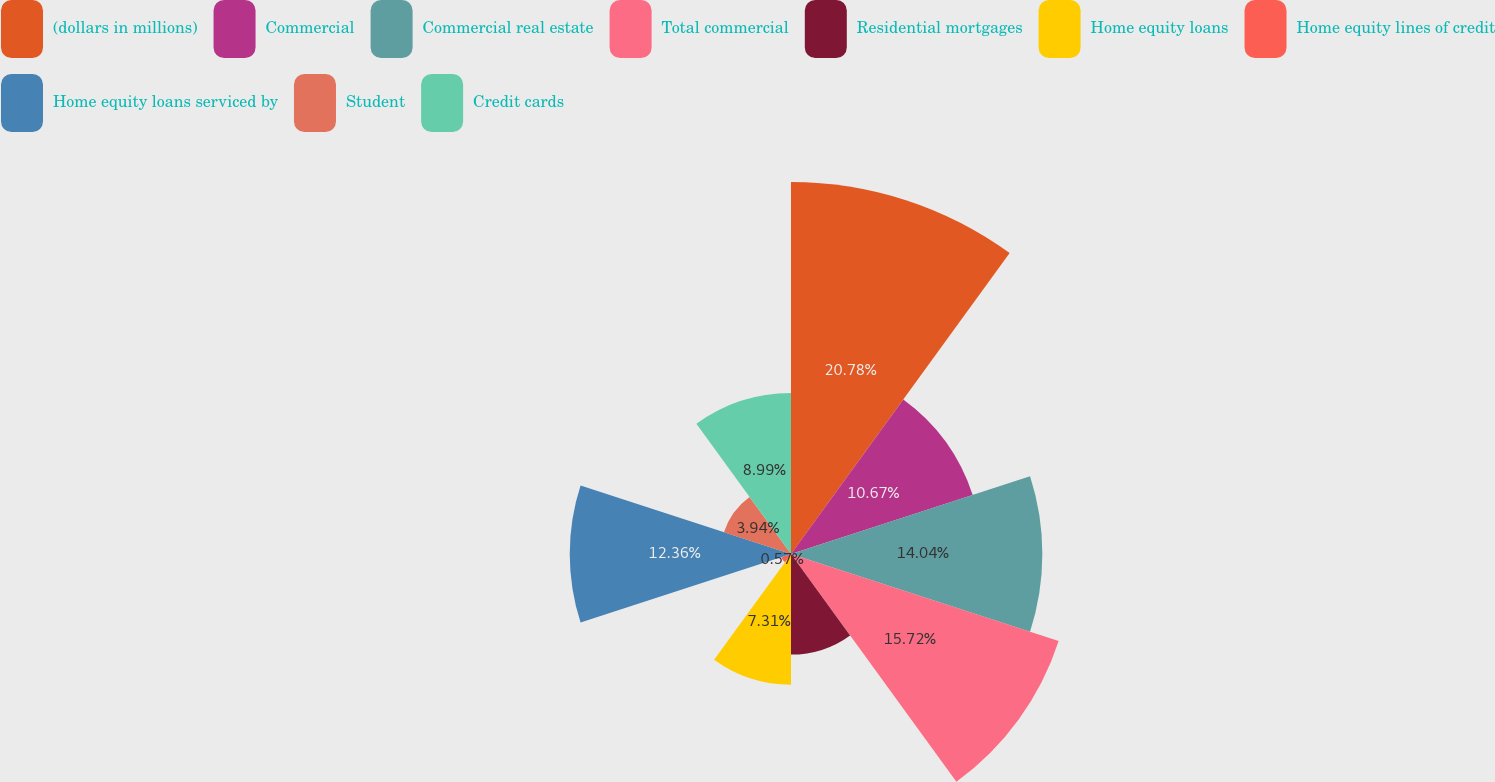Convert chart to OTSL. <chart><loc_0><loc_0><loc_500><loc_500><pie_chart><fcel>(dollars in millions)<fcel>Commercial<fcel>Commercial real estate<fcel>Total commercial<fcel>Residential mortgages<fcel>Home equity loans<fcel>Home equity lines of credit<fcel>Home equity loans serviced by<fcel>Student<fcel>Credit cards<nl><fcel>20.78%<fcel>10.67%<fcel>14.04%<fcel>15.72%<fcel>5.62%<fcel>7.31%<fcel>0.57%<fcel>12.36%<fcel>3.94%<fcel>8.99%<nl></chart> 